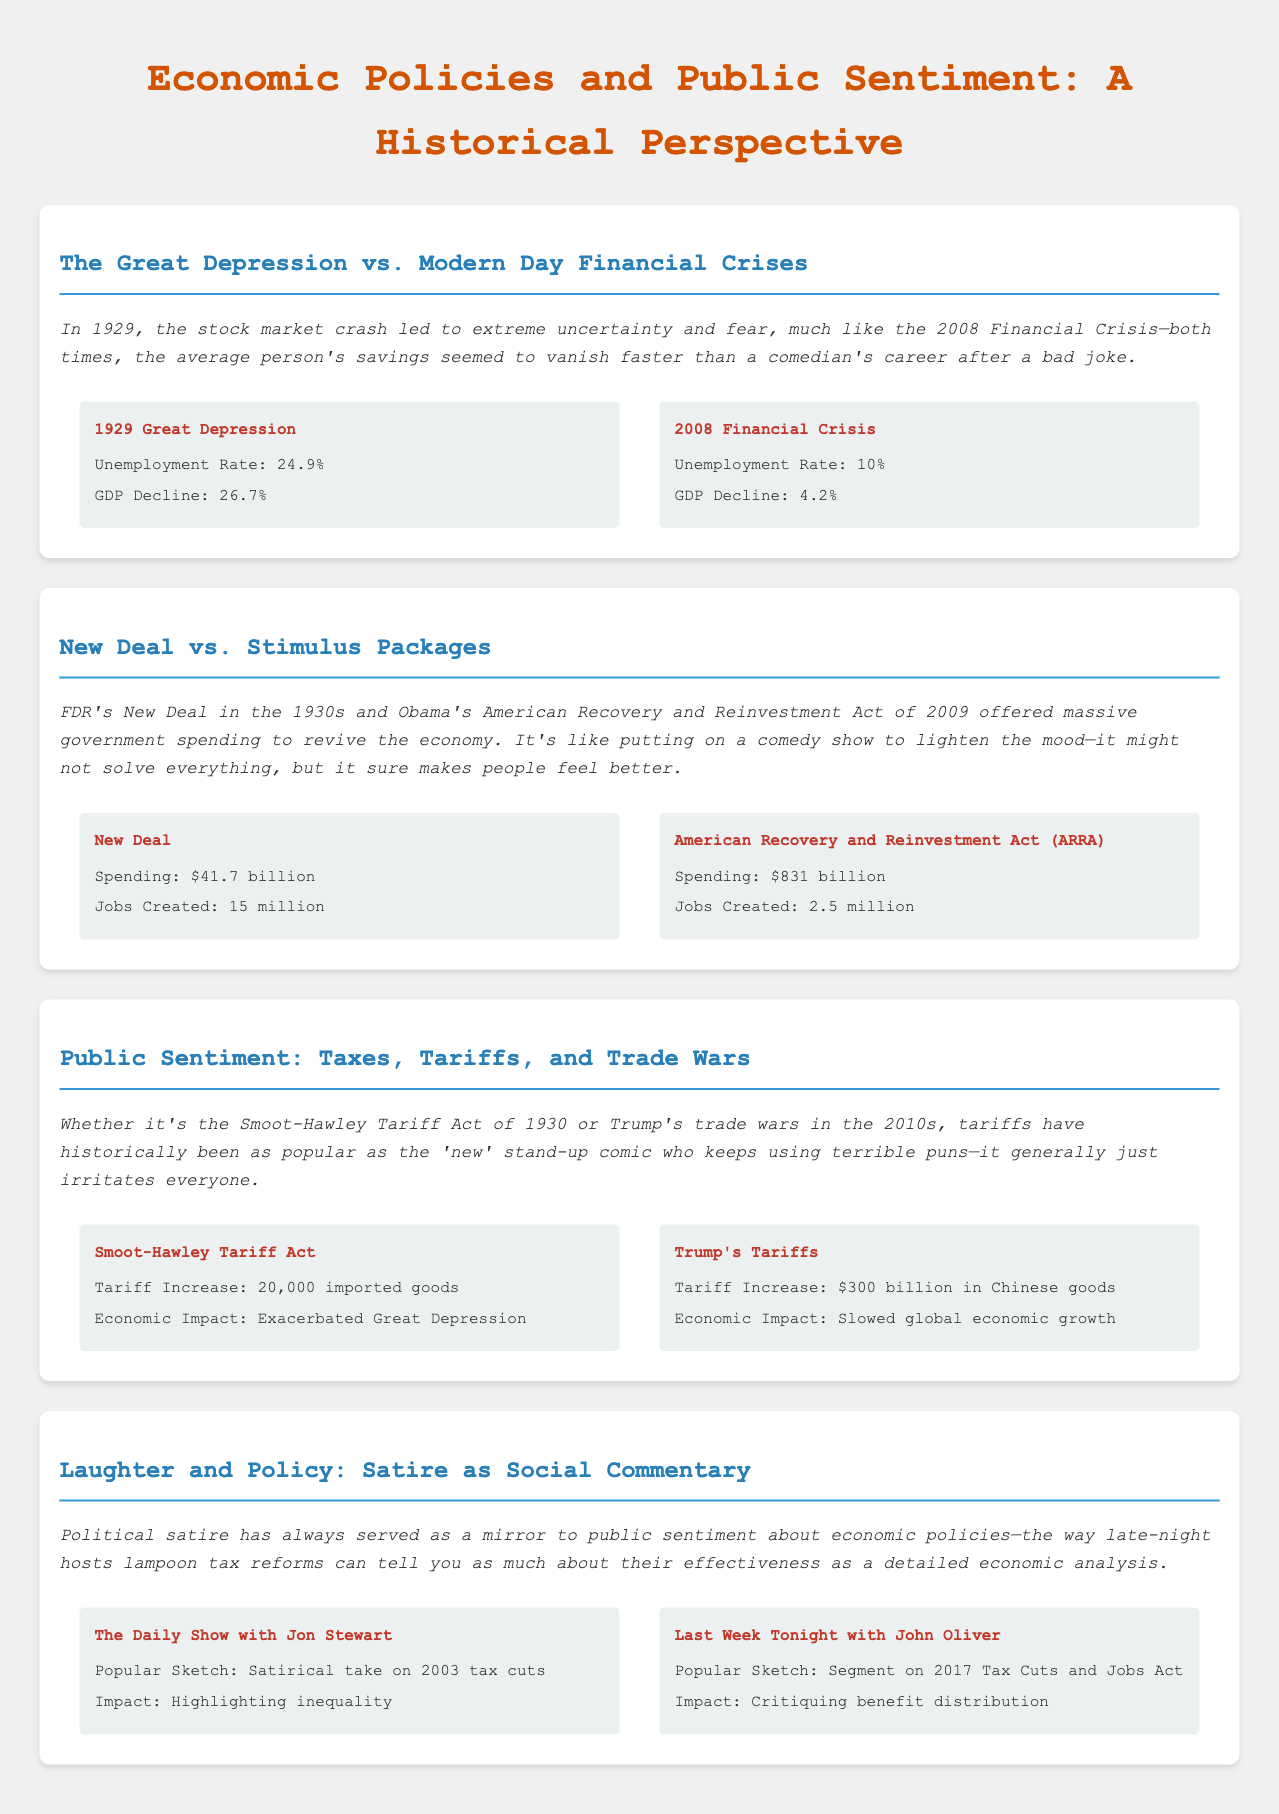What was the unemployment rate during the Great Depression? The unemployment rate is stated as 24.9% in the document.
Answer: 24.9% What was the GDP decline during the 2008 Financial Crisis? The document lists the GDP decline as 4.2% for the 2008 Financial Crisis.
Answer: 4.2% How much did the New Deal spend? The document specifically states the spending amount for the New Deal as $41.7 billion.
Answer: $41.7 billion What economic impact did the Smoot-Hawley Tariff Act have? According to the document, the Smoot-Hawley Tariff Act exacerbated the Great Depression.
Answer: Exacerbated Great Depression Which late-night show highlighted inequality in relation to tax cuts? The document mentions "The Daily Show with Jon Stewart" as the show that highlighted inequality.
Answer: The Daily Show with Jon Stewart What was the tariff increase under Trump's Tariffs? The document states the tariff increase as $300 billion in Chinese goods.
Answer: $300 billion in Chinese goods How many jobs did the American Recovery and Reinvestment Act create? The document provides the number of jobs created by ARRA as 2.5 million.
Answer: 2.5 million What is a notable popular sketch by John Oliver regarding tax legislation? The document notes the segment on the 2017 Tax Cuts and Jobs Act as a popular sketch by John Oliver.
Answer: Segment on 2017 Tax Cuts and Jobs Act How many imported goods were affected by the Smoot-Hawley Tariff Act? The document indicates that the Smoot-Hawley Tariff Act impacted 20,000 imported goods.
Answer: 20,000 imported goods 